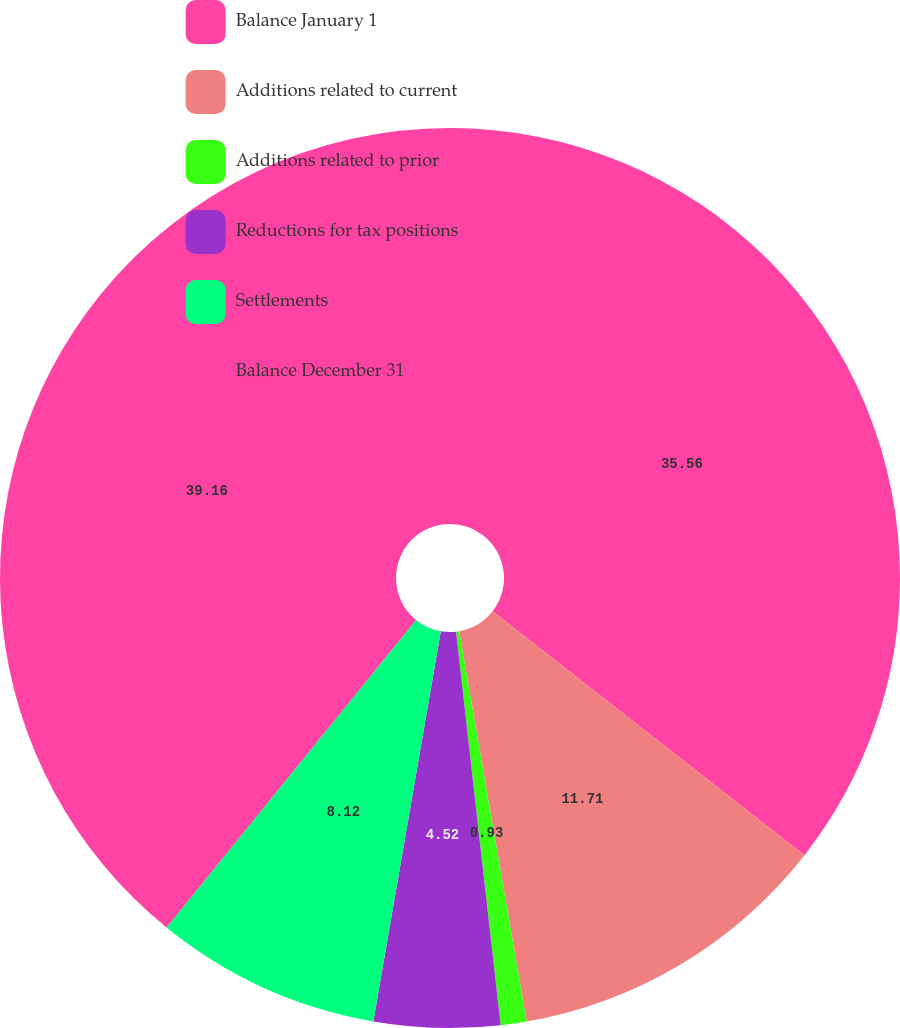Convert chart. <chart><loc_0><loc_0><loc_500><loc_500><pie_chart><fcel>Balance January 1<fcel>Additions related to current<fcel>Additions related to prior<fcel>Reductions for tax positions<fcel>Settlements<fcel>Balance December 31<nl><fcel>35.56%<fcel>11.71%<fcel>0.93%<fcel>4.52%<fcel>8.12%<fcel>39.15%<nl></chart> 